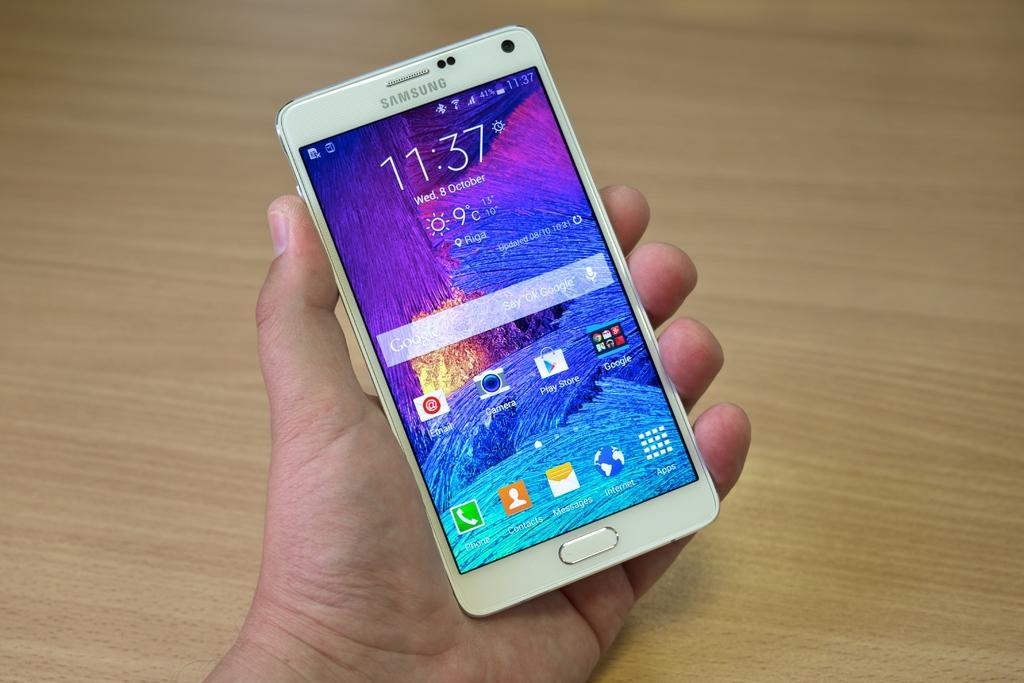<image>
Present a compact description of the photo's key features. The cell phone shows that it is 11:37 on Wednesday, October 8th. 